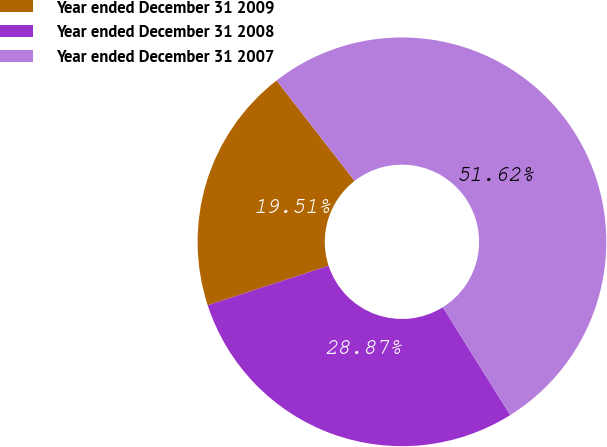Convert chart. <chart><loc_0><loc_0><loc_500><loc_500><pie_chart><fcel>Year ended December 31 2009<fcel>Year ended December 31 2008<fcel>Year ended December 31 2007<nl><fcel>19.51%<fcel>28.87%<fcel>51.63%<nl></chart> 